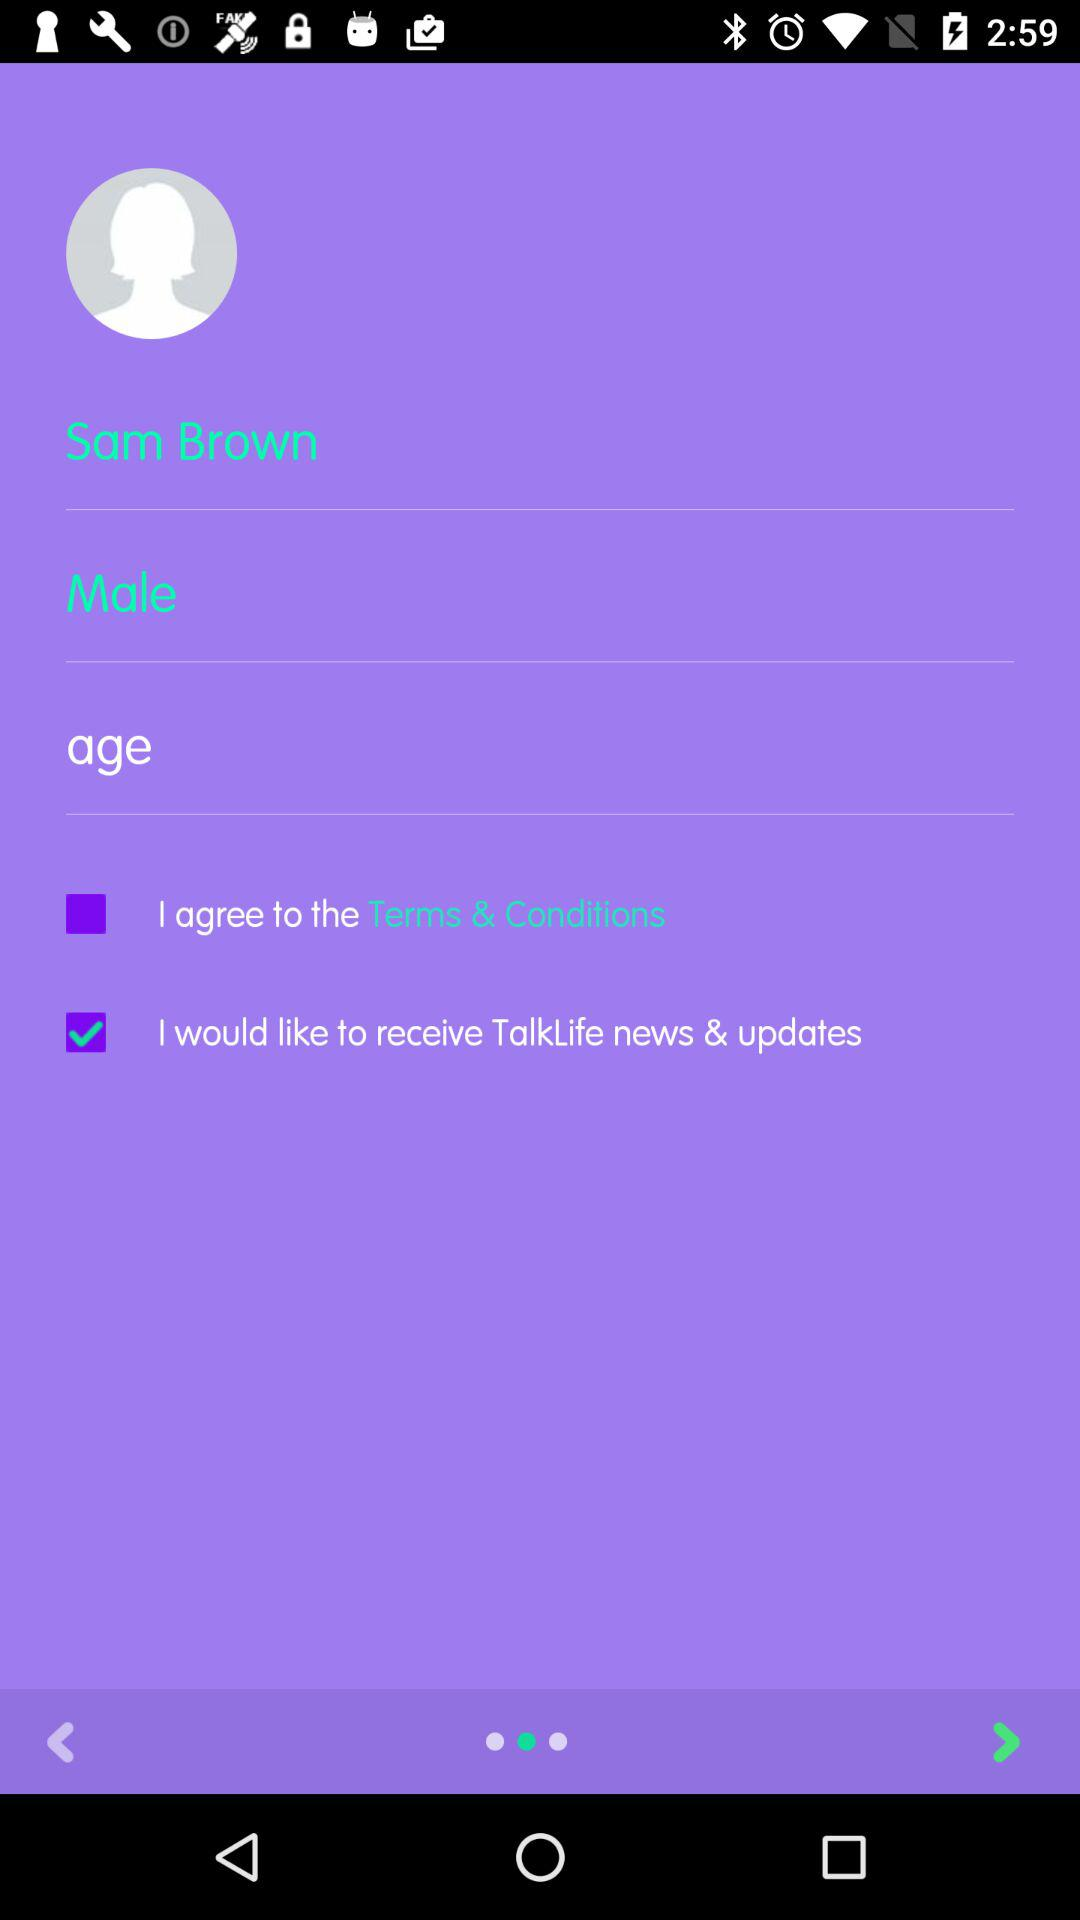Which checkbox is selected? I would like to receive TalkLife news & updates checkbox is selected. 